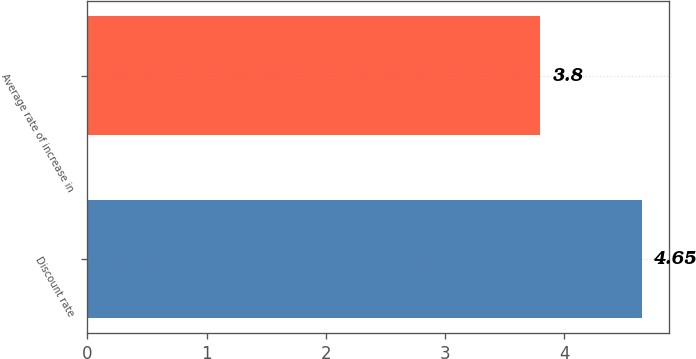<chart> <loc_0><loc_0><loc_500><loc_500><bar_chart><fcel>Discount rate<fcel>Average rate of increase in<nl><fcel>4.65<fcel>3.8<nl></chart> 